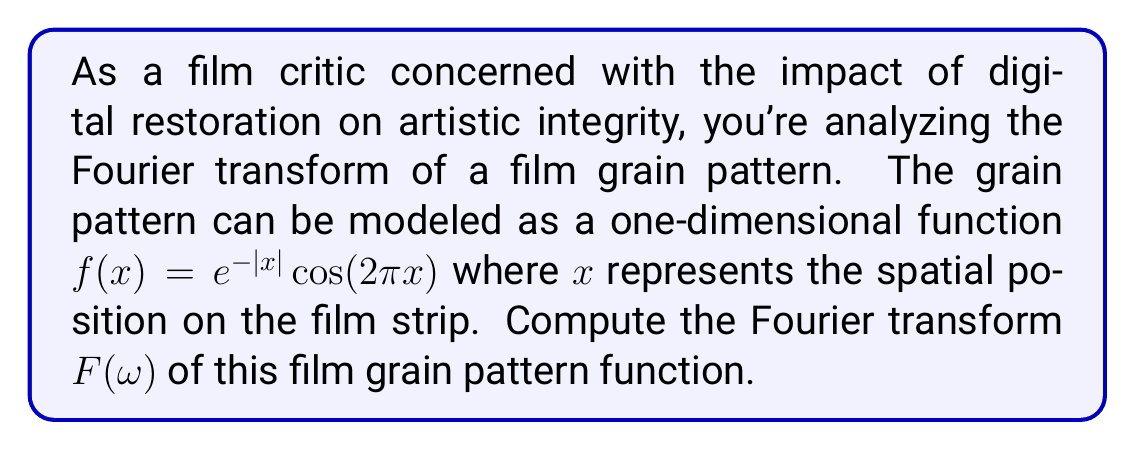Can you answer this question? To compute the Fourier transform, we'll follow these steps:

1) The Fourier transform is defined as:

   $$F(\omega) = \int_{-\infty}^{\infty} f(x)e^{-i\omega x}dx$$

2) Substituting our function $f(x) = e^{-|x|}cos(2\pi x)$:

   $$F(\omega) = \int_{-\infty}^{\infty} e^{-|x|}cos(2\pi x)e^{-i\omega x}dx$$

3) We can split this integral into two parts:

   $$F(\omega) = \int_{0}^{\infty} e^{-x}cos(2\pi x)e^{-i\omega x}dx + \int_{-\infty}^{0} e^{x}cos(2\pi x)e^{-i\omega x}dx$$

4) Using Euler's formula, $cos(2\pi x) = \frac{e^{2\pi ix} + e^{-2\pi ix}}{2}$:

   $$F(\omega) = \frac{1}{2}\int_{0}^{\infty} e^{-x}(e^{2\pi ix} + e^{-2\pi ix})e^{-i\omega x}dx + \frac{1}{2}\int_{-\infty}^{0} e^{x}(e^{2\pi ix} + e^{-2\pi ix})e^{-i\omega x}dx$$

5) Simplifying:

   $$F(\omega) = \frac{1}{2}\int_{0}^{\infty} (e^{-(1+i(\omega-2\pi))x} + e^{-(1+i(\omega+2\pi))x})dx + \frac{1}{2}\int_{-\infty}^{0} (e^{(1-i(\omega-2\pi))x} + e^{(1-i(\omega+2\pi))x})dx$$

6) Evaluating these integrals:

   $$F(\omega) = \frac{1}{2}[\frac{1}{1+i(\omega-2\pi)} + \frac{1}{1+i(\omega+2\pi)}] + \frac{1}{2}[\frac{1}{1-i(\omega-2\pi)} + \frac{1}{1-i(\omega+2\pi)}]$$

7) Combining terms:

   $$F(\omega) = \frac{1}{2}[\frac{1+1-i(\omega-2\pi)}{(1+i(\omega-2\pi))(1-i(\omega-2\pi))} + \frac{1+1-i(\omega+2\pi)}{(1+i(\omega+2\pi))(1-i(\omega+2\pi))}]$$

8) Simplifying:

   $$F(\omega) = \frac{1}{2}[\frac{2-i(\omega-2\pi)}{1+(\omega-2\pi)^2} + \frac{2-i(\omega+2\pi)}{1+(\omega+2\pi)^2}]$$

9) This can be written as:

   $$F(\omega) = \frac{2-i(\omega-2\pi)}{1+(\omega-2\pi)^2} + \frac{2-i(\omega+2\pi)}{1+(\omega+2\pi)^2}$$
Answer: $$F(\omega) = \frac{2-i(\omega-2\pi)}{1+(\omega-2\pi)^2} + \frac{2-i(\omega+2\pi)}{1+(\omega+2\pi)^2}$$ 